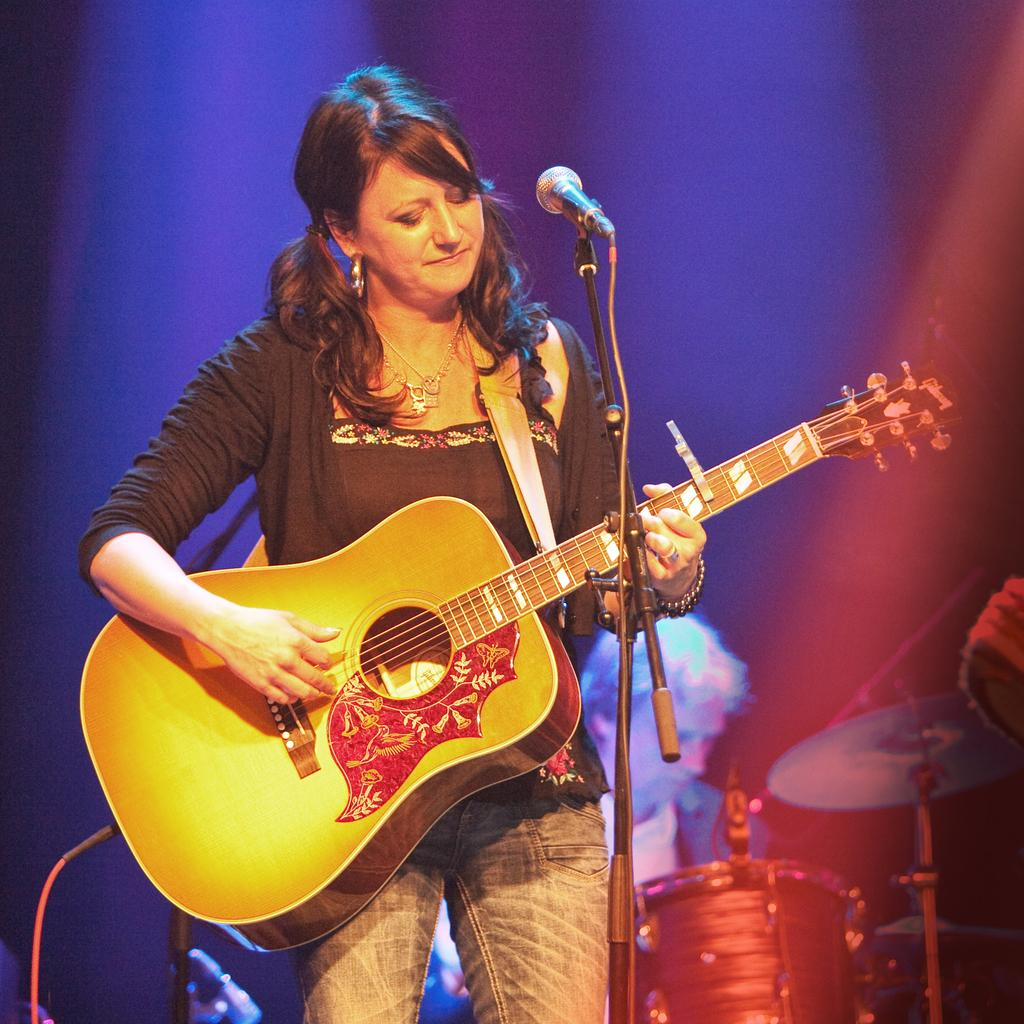What is the woman in the image doing? The woman is standing and playing a guitar in the image. What object is present that is typically used for amplifying sound? There is a microphone in the image. What is the man in the image doing? The man is seated and playing drums in the image. What type of shoe can be seen floating in the waves in the image? There is no shoe or waves present in the image; it features a woman playing a guitar and a man playing drums. 